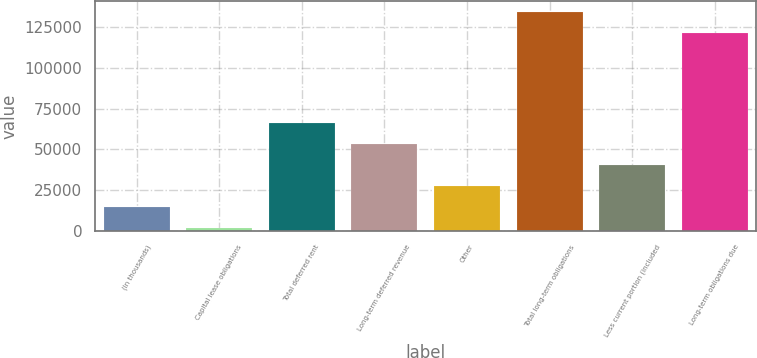<chart> <loc_0><loc_0><loc_500><loc_500><bar_chart><fcel>(In thousands)<fcel>Capital lease obligations<fcel>Total deferred rent<fcel>Long-term deferred revenue<fcel>Other<fcel>Total long-term obligations<fcel>Less current portion (included<fcel>Long-term obligations due<nl><fcel>14460.9<fcel>1562<fcel>66056.5<fcel>53157.6<fcel>27359.8<fcel>134388<fcel>40258.7<fcel>121489<nl></chart> 